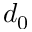Convert formula to latex. <formula><loc_0><loc_0><loc_500><loc_500>d _ { 0 }</formula> 